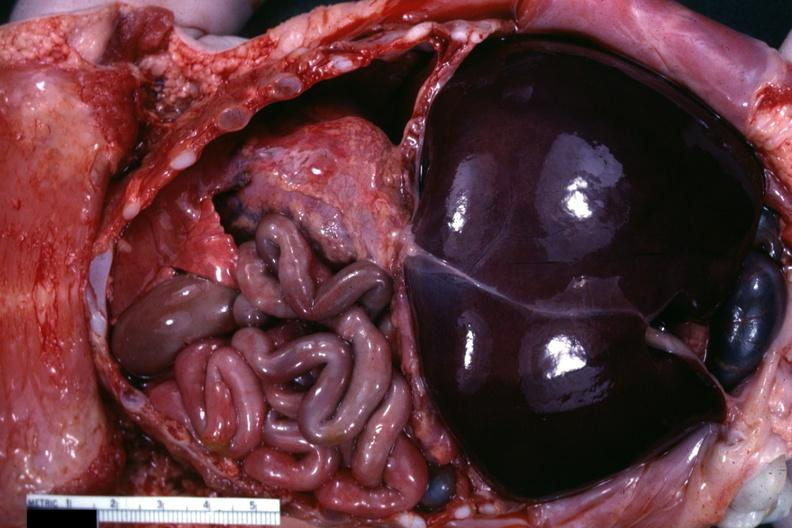s soft tissue present?
Answer the question using a single word or phrase. Yes 